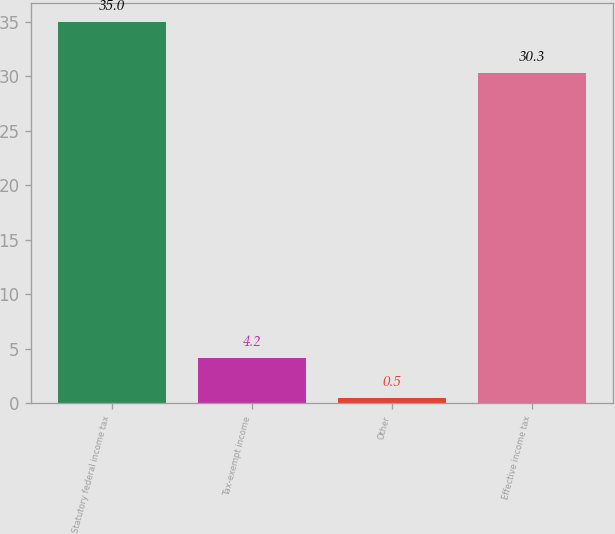Convert chart. <chart><loc_0><loc_0><loc_500><loc_500><bar_chart><fcel>Statutory federal income tax<fcel>Tax-exempt income<fcel>Other<fcel>Effective income tax<nl><fcel>35<fcel>4.2<fcel>0.5<fcel>30.3<nl></chart> 